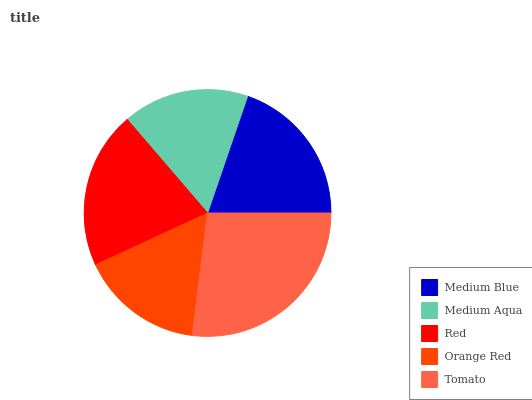Is Orange Red the minimum?
Answer yes or no. Yes. Is Tomato the maximum?
Answer yes or no. Yes. Is Medium Aqua the minimum?
Answer yes or no. No. Is Medium Aqua the maximum?
Answer yes or no. No. Is Medium Blue greater than Medium Aqua?
Answer yes or no. Yes. Is Medium Aqua less than Medium Blue?
Answer yes or no. Yes. Is Medium Aqua greater than Medium Blue?
Answer yes or no. No. Is Medium Blue less than Medium Aqua?
Answer yes or no. No. Is Medium Blue the high median?
Answer yes or no. Yes. Is Medium Blue the low median?
Answer yes or no. Yes. Is Orange Red the high median?
Answer yes or no. No. Is Tomato the low median?
Answer yes or no. No. 